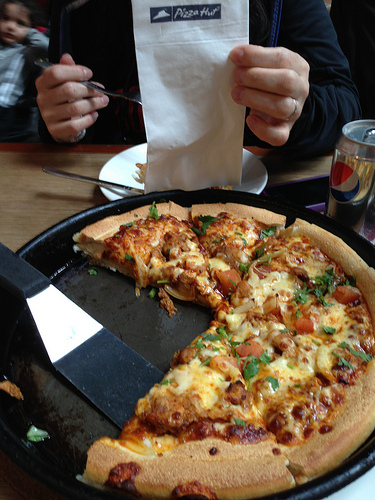Please provide the bounding box coordinate of the region this sentence describes: Child standing behind the man staring at the camera. The child standing behind the man and staring at the camera is within the coordinates [0.12, 0.0, 0.22, 0.29]. 